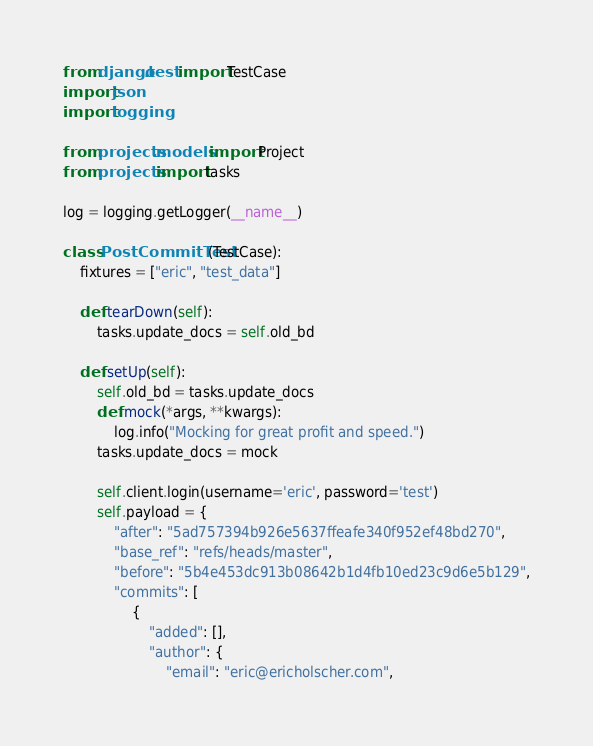<code> <loc_0><loc_0><loc_500><loc_500><_Python_>from django.test import TestCase
import json
import logging

from projects.models import Project
from projects import tasks

log = logging.getLogger(__name__)

class PostCommitTest(TestCase):
    fixtures = ["eric", "test_data"]

    def tearDown(self):
        tasks.update_docs = self.old_bd

    def setUp(self):
        self.old_bd = tasks.update_docs
        def mock(*args, **kwargs):
            log.info("Mocking for great profit and speed.")
        tasks.update_docs = mock

        self.client.login(username='eric', password='test')
        self.payload = {
            "after": "5ad757394b926e5637ffeafe340f952ef48bd270",
            "base_ref": "refs/heads/master",
            "before": "5b4e453dc913b08642b1d4fb10ed23c9d6e5b129",
            "commits": [
                {
                    "added": [],
                    "author": {
                        "email": "eric@ericholscher.com",</code> 